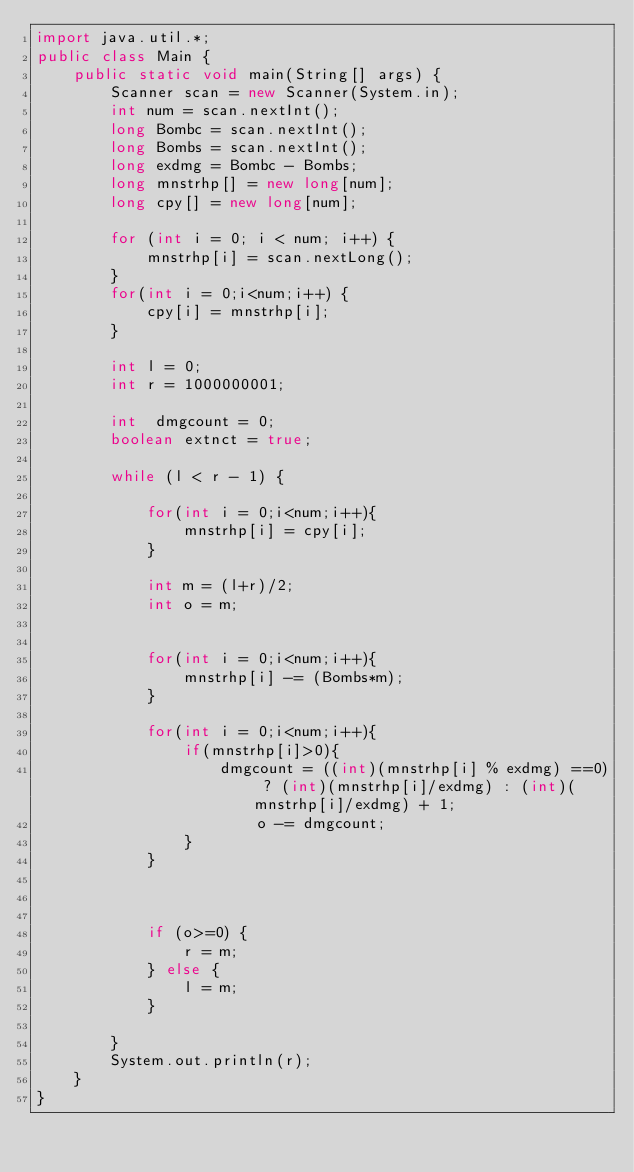<code> <loc_0><loc_0><loc_500><loc_500><_Java_>import java.util.*;
public class Main {
    public static void main(String[] args) {
        Scanner scan = new Scanner(System.in);
        int num = scan.nextInt();
        long Bombc = scan.nextInt();
        long Bombs = scan.nextInt();
        long exdmg = Bombc - Bombs;
        long mnstrhp[] = new long[num];
        long cpy[] = new long[num];

        for (int i = 0; i < num; i++) {
            mnstrhp[i] = scan.nextLong();
        }
        for(int i = 0;i<num;i++) {
            cpy[i] = mnstrhp[i];
        }

        int l = 0;
        int r = 1000000001;

        int  dmgcount = 0;
        boolean extnct = true;

        while (l < r - 1) {

            for(int i = 0;i<num;i++){
                mnstrhp[i] = cpy[i];
            }

            int m = (l+r)/2;
            int o = m;


            for(int i = 0;i<num;i++){
                mnstrhp[i] -= (Bombs*m);
            }

            for(int i = 0;i<num;i++){
                if(mnstrhp[i]>0){
                    dmgcount = ((int)(mnstrhp[i] % exdmg) ==0) ? (int)(mnstrhp[i]/exdmg) : (int)(mnstrhp[i]/exdmg) + 1;
                        o -= dmgcount;
                }
            }



            if (o>=0) {
                r = m;
            } else {
                l = m;
            }

        }
        System.out.println(r);
    }
}
</code> 